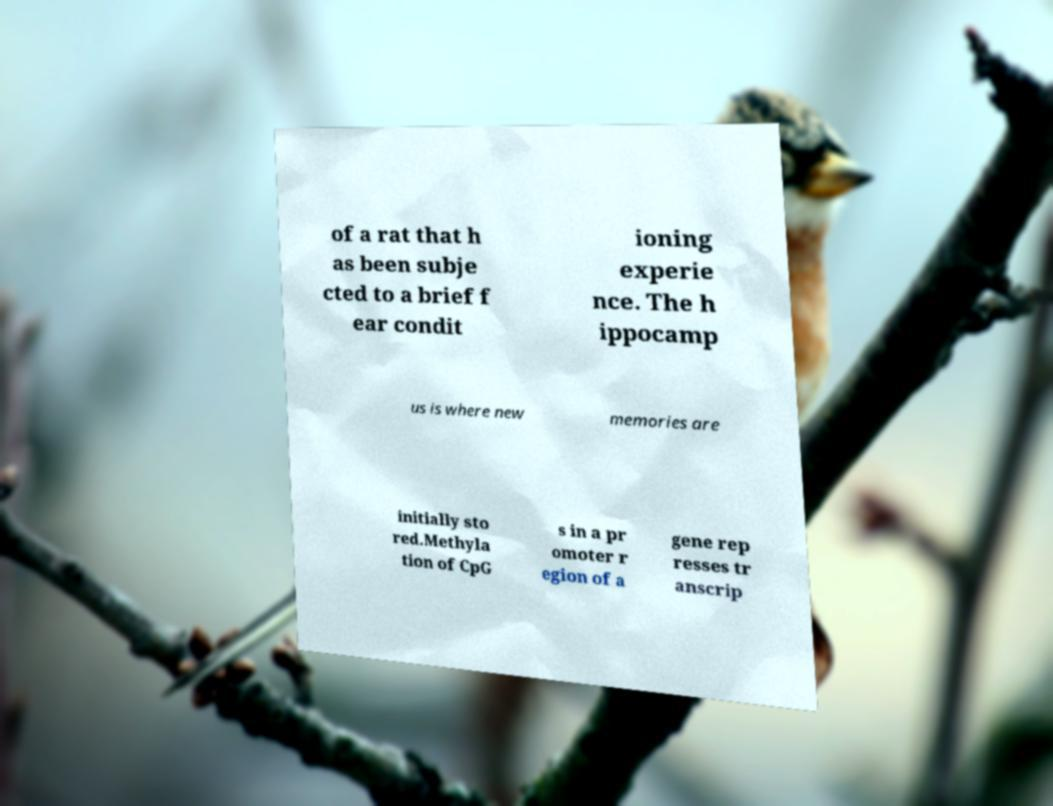Could you assist in decoding the text presented in this image and type it out clearly? of a rat that h as been subje cted to a brief f ear condit ioning experie nce. The h ippocamp us is where new memories are initially sto red.Methyla tion of CpG s in a pr omoter r egion of a gene rep resses tr anscrip 